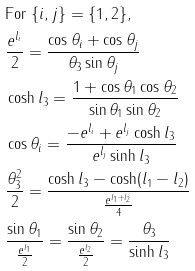<formula> <loc_0><loc_0><loc_500><loc_500>& \text {For} \ \{ i , j \} = \{ 1 , 2 \} , & \\ & \frac { e ^ { l _ { i } } } 2 = \frac { \cos \theta _ { i } + \cos \theta _ { j } } { \theta _ { 3 } \sin \theta _ { j } } & \\ & \cosh l _ { 3 } = \frac { 1 + \cos \theta _ { 1 } \cos \theta _ { 2 } } { \sin \theta _ { 1 } \sin \theta _ { 2 } } & \\ & \cos \theta _ { i } = \frac { - e ^ { l _ { i } } + e ^ { l _ { j } } \cosh l _ { 3 } } { e ^ { l _ { j } } \sinh l _ { 3 } } & \\ & \frac { \theta _ { 3 } ^ { 2 } } { 2 } = \frac { \cosh l _ { 3 } - \cosh ( l _ { 1 } - l _ { 2 } ) } { \frac { e ^ { l _ { 1 } + l _ { 2 } } } 4 } & \\ & \frac { \sin \theta _ { 1 } } { \frac { e ^ { l _ { 1 } } } 2 } = \frac { \sin \theta _ { 2 } } { \frac { e ^ { l _ { 2 } } } 2 } = \frac { \theta _ { 3 } } { \sinh l _ { 3 } } &</formula> 